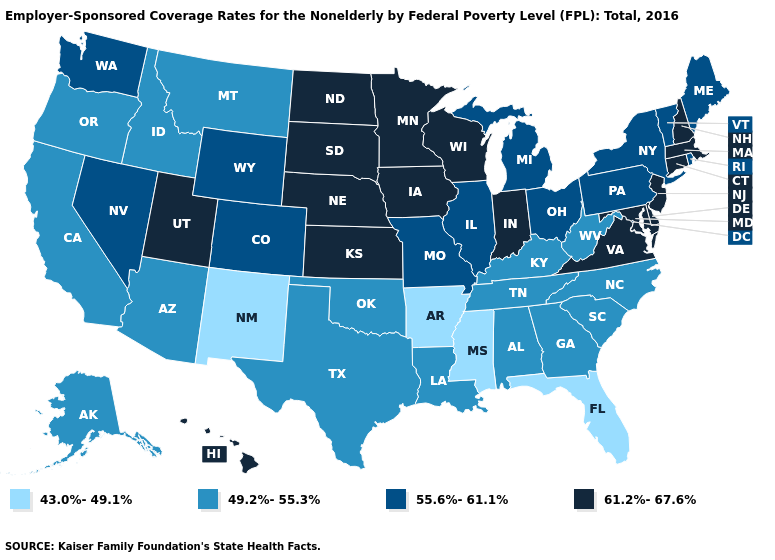Does Kentucky have the lowest value in the South?
Write a very short answer. No. Name the states that have a value in the range 61.2%-67.6%?
Concise answer only. Connecticut, Delaware, Hawaii, Indiana, Iowa, Kansas, Maryland, Massachusetts, Minnesota, Nebraska, New Hampshire, New Jersey, North Dakota, South Dakota, Utah, Virginia, Wisconsin. Does Washington have the highest value in the USA?
Be succinct. No. Does Connecticut have the lowest value in the Northeast?
Short answer required. No. What is the lowest value in states that border Vermont?
Be succinct. 55.6%-61.1%. Does Michigan have the highest value in the MidWest?
Quick response, please. No. What is the value of Maryland?
Answer briefly. 61.2%-67.6%. Does Michigan have a lower value than Virginia?
Give a very brief answer. Yes. Which states hav the highest value in the Northeast?
Short answer required. Connecticut, Massachusetts, New Hampshire, New Jersey. What is the value of Georgia?
Answer briefly. 49.2%-55.3%. Does Montana have the highest value in the USA?
Keep it brief. No. What is the highest value in states that border Connecticut?
Short answer required. 61.2%-67.6%. What is the value of Colorado?
Concise answer only. 55.6%-61.1%. Which states have the highest value in the USA?
Be succinct. Connecticut, Delaware, Hawaii, Indiana, Iowa, Kansas, Maryland, Massachusetts, Minnesota, Nebraska, New Hampshire, New Jersey, North Dakota, South Dakota, Utah, Virginia, Wisconsin. What is the value of Rhode Island?
Give a very brief answer. 55.6%-61.1%. 